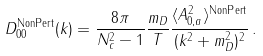Convert formula to latex. <formula><loc_0><loc_0><loc_500><loc_500>D ^ { \text {NonPert} } _ { 0 0 } ( k ) = \frac { 8 \pi } { N _ { c } ^ { 2 } - 1 } \frac { m _ { D } } { T } \frac { \langle A _ { 0 , a } ^ { 2 } \rangle ^ { \text {NonPert} } } { ( k ^ { 2 } + m _ { D } ^ { 2 } ) ^ { 2 } } \, .</formula> 